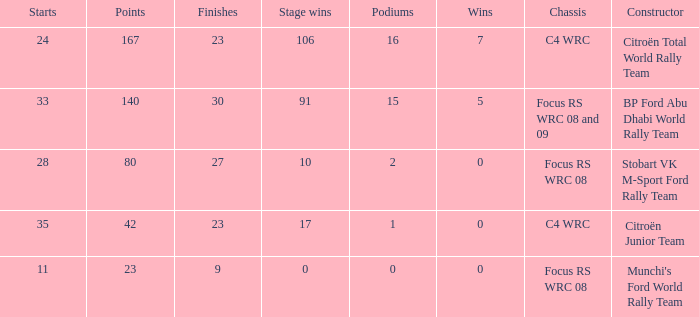What is the average wins when the podiums is more than 1, points is 80 and starts is less than 28? None. 